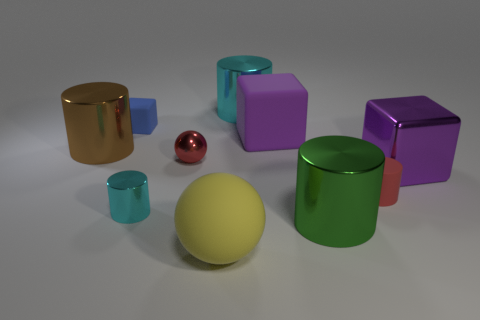What material is the other cube that is the same color as the big rubber cube?
Your answer should be very brief. Metal. How many other green cylinders have the same size as the green metal cylinder?
Keep it short and to the point. 0. Is the number of big brown objects in front of the large brown metallic cylinder less than the number of big purple blocks behind the shiny ball?
Your answer should be very brief. Yes. What number of metal objects are blue cubes or big green cylinders?
Your answer should be very brief. 1. What is the shape of the large brown shiny thing?
Keep it short and to the point. Cylinder. There is another cyan cylinder that is the same size as the matte cylinder; what material is it?
Offer a very short reply. Metal. How many big things are either red objects or gray balls?
Offer a terse response. 0. Is there a large gray block?
Provide a short and direct response. No. There is a red cylinder that is the same material as the small blue block; what is its size?
Offer a very short reply. Small. Do the big brown thing and the big green object have the same material?
Keep it short and to the point. Yes. 